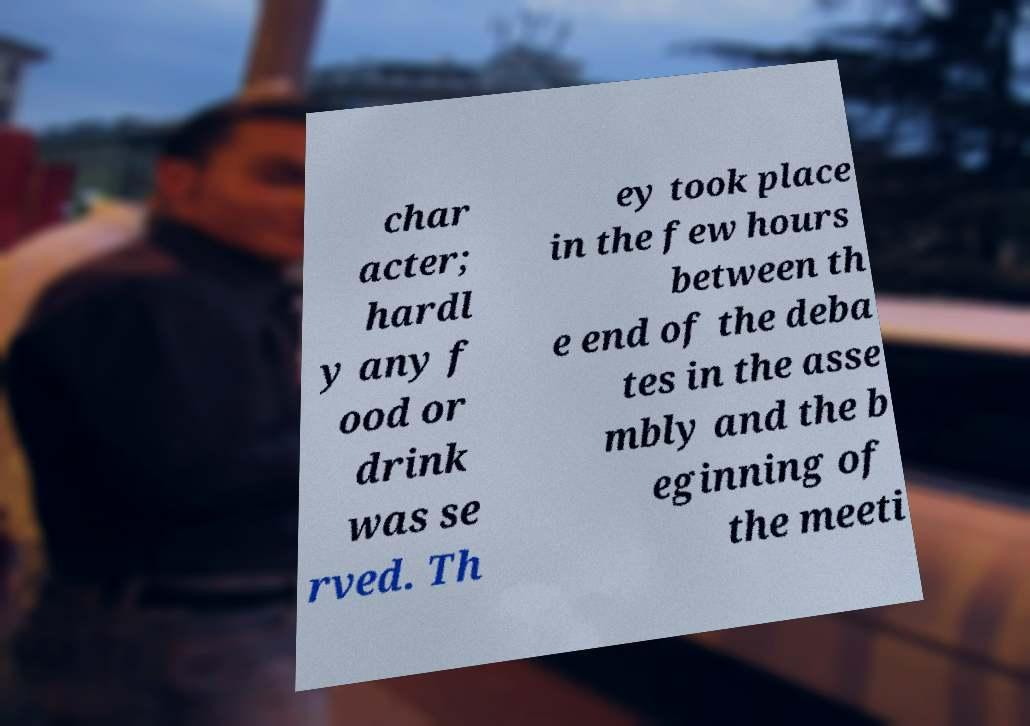Can you accurately transcribe the text from the provided image for me? char acter; hardl y any f ood or drink was se rved. Th ey took place in the few hours between th e end of the deba tes in the asse mbly and the b eginning of the meeti 